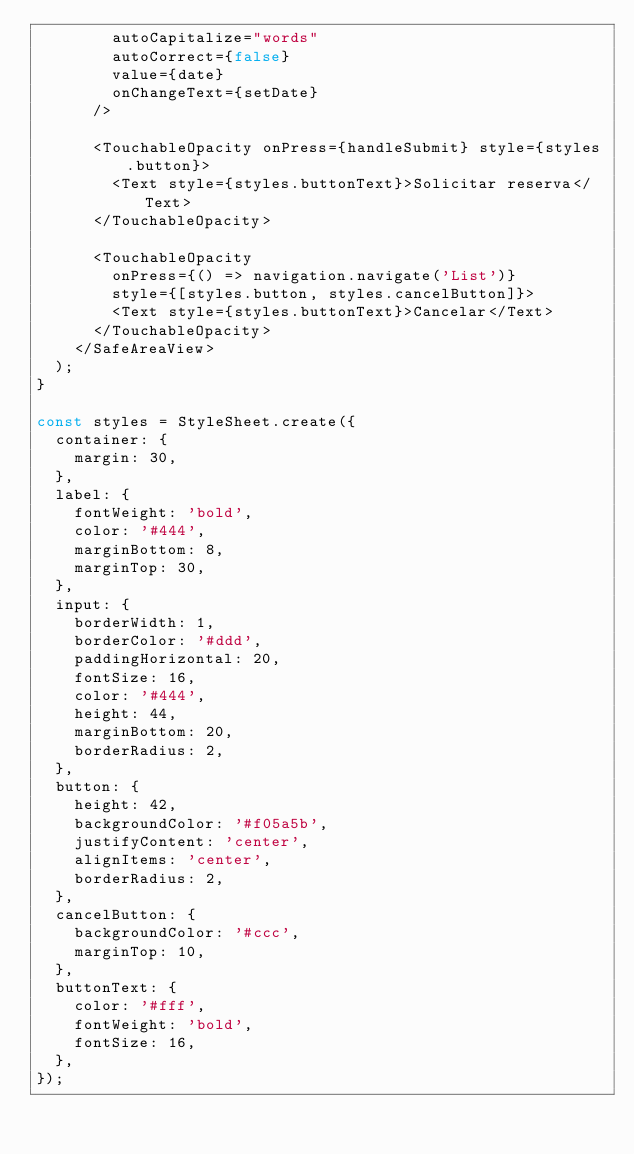Convert code to text. <code><loc_0><loc_0><loc_500><loc_500><_JavaScript_>        autoCapitalize="words"
        autoCorrect={false}
        value={date}
        onChangeText={setDate}
      />

      <TouchableOpacity onPress={handleSubmit} style={styles.button}>
        <Text style={styles.buttonText}>Solicitar reserva</Text>
      </TouchableOpacity>

      <TouchableOpacity
        onPress={() => navigation.navigate('List')}
        style={[styles.button, styles.cancelButton]}>
        <Text style={styles.buttonText}>Cancelar</Text>
      </TouchableOpacity>
    </SafeAreaView>
  );
}

const styles = StyleSheet.create({
  container: {
    margin: 30,
  },
  label: {
    fontWeight: 'bold',
    color: '#444',
    marginBottom: 8,
    marginTop: 30,
  },
  input: {
    borderWidth: 1,
    borderColor: '#ddd',
    paddingHorizontal: 20,
    fontSize: 16,
    color: '#444',
    height: 44,
    marginBottom: 20,
    borderRadius: 2,
  },
  button: {
    height: 42,
    backgroundColor: '#f05a5b',
    justifyContent: 'center',
    alignItems: 'center',
    borderRadius: 2,
  },
  cancelButton: {
    backgroundColor: '#ccc',
    marginTop: 10,
  },
  buttonText: {
    color: '#fff',
    fontWeight: 'bold',
    fontSize: 16,
  },
});
</code> 